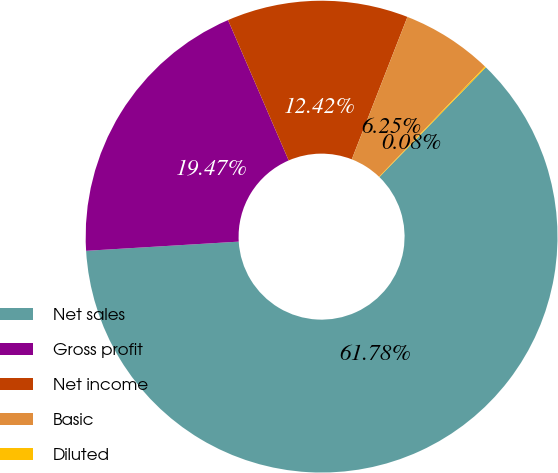<chart> <loc_0><loc_0><loc_500><loc_500><pie_chart><fcel>Net sales<fcel>Gross profit<fcel>Net income<fcel>Basic<fcel>Diluted<nl><fcel>61.79%<fcel>19.47%<fcel>12.42%<fcel>6.25%<fcel>0.08%<nl></chart> 